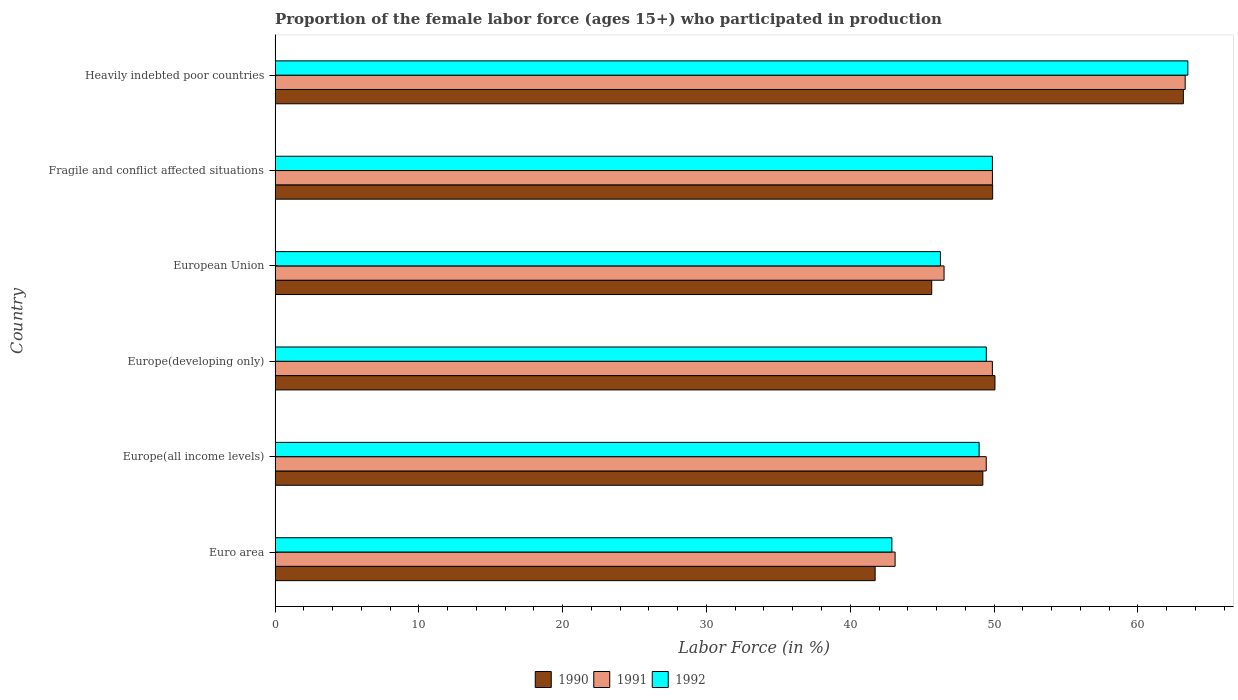How many groups of bars are there?
Your answer should be compact. 6. Are the number of bars per tick equal to the number of legend labels?
Make the answer very short. Yes. Are the number of bars on each tick of the Y-axis equal?
Your response must be concise. Yes. How many bars are there on the 1st tick from the bottom?
Ensure brevity in your answer.  3. What is the label of the 2nd group of bars from the top?
Ensure brevity in your answer.  Fragile and conflict affected situations. What is the proportion of the female labor force who participated in production in 1992 in Heavily indebted poor countries?
Make the answer very short. 63.48. Across all countries, what is the maximum proportion of the female labor force who participated in production in 1990?
Keep it short and to the point. 63.16. Across all countries, what is the minimum proportion of the female labor force who participated in production in 1991?
Offer a terse response. 43.12. In which country was the proportion of the female labor force who participated in production in 1990 maximum?
Provide a short and direct response. Heavily indebted poor countries. What is the total proportion of the female labor force who participated in production in 1990 in the graph?
Offer a terse response. 299.74. What is the difference between the proportion of the female labor force who participated in production in 1990 in Euro area and that in Europe(developing only)?
Your response must be concise. -8.33. What is the difference between the proportion of the female labor force who participated in production in 1990 in Euro area and the proportion of the female labor force who participated in production in 1992 in Fragile and conflict affected situations?
Give a very brief answer. -8.15. What is the average proportion of the female labor force who participated in production in 1992 per country?
Your answer should be compact. 50.16. What is the difference between the proportion of the female labor force who participated in production in 1991 and proportion of the female labor force who participated in production in 1992 in Europe(developing only)?
Your response must be concise. 0.42. What is the ratio of the proportion of the female labor force who participated in production in 1992 in Europe(all income levels) to that in Fragile and conflict affected situations?
Give a very brief answer. 0.98. Is the proportion of the female labor force who participated in production in 1992 in Euro area less than that in Heavily indebted poor countries?
Give a very brief answer. Yes. What is the difference between the highest and the second highest proportion of the female labor force who participated in production in 1991?
Offer a terse response. 13.4. What is the difference between the highest and the lowest proportion of the female labor force who participated in production in 1991?
Offer a very short reply. 20.17. In how many countries, is the proportion of the female labor force who participated in production in 1992 greater than the average proportion of the female labor force who participated in production in 1992 taken over all countries?
Keep it short and to the point. 1. Is the sum of the proportion of the female labor force who participated in production in 1992 in Europe(developing only) and Fragile and conflict affected situations greater than the maximum proportion of the female labor force who participated in production in 1991 across all countries?
Ensure brevity in your answer.  Yes. What does the 1st bar from the top in Europe(developing only) represents?
Your answer should be very brief. 1992. What does the 1st bar from the bottom in Europe(all income levels) represents?
Provide a succinct answer. 1990. How many bars are there?
Provide a succinct answer. 18. Are all the bars in the graph horizontal?
Ensure brevity in your answer.  Yes. How many countries are there in the graph?
Make the answer very short. 6. Where does the legend appear in the graph?
Offer a very short reply. Bottom center. What is the title of the graph?
Provide a succinct answer. Proportion of the female labor force (ages 15+) who participated in production. What is the label or title of the X-axis?
Provide a short and direct response. Labor Force (in %). What is the Labor Force (in %) of 1990 in Euro area?
Your answer should be compact. 41.73. What is the Labor Force (in %) of 1991 in Euro area?
Your answer should be very brief. 43.12. What is the Labor Force (in %) in 1992 in Euro area?
Give a very brief answer. 42.89. What is the Labor Force (in %) of 1990 in Europe(all income levels)?
Give a very brief answer. 49.22. What is the Labor Force (in %) of 1991 in Europe(all income levels)?
Offer a terse response. 49.46. What is the Labor Force (in %) in 1992 in Europe(all income levels)?
Provide a short and direct response. 48.96. What is the Labor Force (in %) of 1990 in Europe(developing only)?
Make the answer very short. 50.06. What is the Labor Force (in %) in 1991 in Europe(developing only)?
Ensure brevity in your answer.  49.88. What is the Labor Force (in %) in 1992 in Europe(developing only)?
Ensure brevity in your answer.  49.46. What is the Labor Force (in %) in 1990 in European Union?
Offer a terse response. 45.66. What is the Labor Force (in %) of 1991 in European Union?
Provide a short and direct response. 46.52. What is the Labor Force (in %) of 1992 in European Union?
Offer a very short reply. 46.27. What is the Labor Force (in %) in 1990 in Fragile and conflict affected situations?
Offer a terse response. 49.9. What is the Labor Force (in %) of 1991 in Fragile and conflict affected situations?
Make the answer very short. 49.89. What is the Labor Force (in %) of 1992 in Fragile and conflict affected situations?
Give a very brief answer. 49.88. What is the Labor Force (in %) of 1990 in Heavily indebted poor countries?
Offer a terse response. 63.16. What is the Labor Force (in %) in 1991 in Heavily indebted poor countries?
Your response must be concise. 63.29. What is the Labor Force (in %) in 1992 in Heavily indebted poor countries?
Your answer should be compact. 63.48. Across all countries, what is the maximum Labor Force (in %) of 1990?
Ensure brevity in your answer.  63.16. Across all countries, what is the maximum Labor Force (in %) of 1991?
Keep it short and to the point. 63.29. Across all countries, what is the maximum Labor Force (in %) of 1992?
Offer a very short reply. 63.48. Across all countries, what is the minimum Labor Force (in %) of 1990?
Provide a succinct answer. 41.73. Across all countries, what is the minimum Labor Force (in %) of 1991?
Provide a short and direct response. 43.12. Across all countries, what is the minimum Labor Force (in %) in 1992?
Provide a short and direct response. 42.89. What is the total Labor Force (in %) in 1990 in the graph?
Your answer should be compact. 299.74. What is the total Labor Force (in %) of 1991 in the graph?
Your response must be concise. 302.16. What is the total Labor Force (in %) in 1992 in the graph?
Offer a very short reply. 300.95. What is the difference between the Labor Force (in %) in 1990 in Euro area and that in Europe(all income levels)?
Offer a terse response. -7.49. What is the difference between the Labor Force (in %) of 1991 in Euro area and that in Europe(all income levels)?
Your answer should be very brief. -6.34. What is the difference between the Labor Force (in %) in 1992 in Euro area and that in Europe(all income levels)?
Offer a very short reply. -6.07. What is the difference between the Labor Force (in %) in 1990 in Euro area and that in Europe(developing only)?
Give a very brief answer. -8.33. What is the difference between the Labor Force (in %) in 1991 in Euro area and that in Europe(developing only)?
Provide a succinct answer. -6.76. What is the difference between the Labor Force (in %) in 1992 in Euro area and that in Europe(developing only)?
Provide a short and direct response. -6.57. What is the difference between the Labor Force (in %) of 1990 in Euro area and that in European Union?
Keep it short and to the point. -3.93. What is the difference between the Labor Force (in %) of 1991 in Euro area and that in European Union?
Your answer should be compact. -3.4. What is the difference between the Labor Force (in %) of 1992 in Euro area and that in European Union?
Offer a terse response. -3.38. What is the difference between the Labor Force (in %) of 1990 in Euro area and that in Fragile and conflict affected situations?
Make the answer very short. -8.17. What is the difference between the Labor Force (in %) of 1991 in Euro area and that in Fragile and conflict affected situations?
Your answer should be very brief. -6.77. What is the difference between the Labor Force (in %) in 1992 in Euro area and that in Fragile and conflict affected situations?
Offer a terse response. -6.99. What is the difference between the Labor Force (in %) in 1990 in Euro area and that in Heavily indebted poor countries?
Offer a very short reply. -21.43. What is the difference between the Labor Force (in %) in 1991 in Euro area and that in Heavily indebted poor countries?
Ensure brevity in your answer.  -20.17. What is the difference between the Labor Force (in %) of 1992 in Euro area and that in Heavily indebted poor countries?
Offer a terse response. -20.58. What is the difference between the Labor Force (in %) of 1990 in Europe(all income levels) and that in Europe(developing only)?
Give a very brief answer. -0.84. What is the difference between the Labor Force (in %) of 1991 in Europe(all income levels) and that in Europe(developing only)?
Ensure brevity in your answer.  -0.43. What is the difference between the Labor Force (in %) in 1992 in Europe(all income levels) and that in Europe(developing only)?
Your answer should be very brief. -0.5. What is the difference between the Labor Force (in %) of 1990 in Europe(all income levels) and that in European Union?
Offer a very short reply. 3.56. What is the difference between the Labor Force (in %) of 1991 in Europe(all income levels) and that in European Union?
Provide a short and direct response. 2.93. What is the difference between the Labor Force (in %) in 1992 in Europe(all income levels) and that in European Union?
Offer a very short reply. 2.69. What is the difference between the Labor Force (in %) of 1990 in Europe(all income levels) and that in Fragile and conflict affected situations?
Offer a terse response. -0.68. What is the difference between the Labor Force (in %) of 1991 in Europe(all income levels) and that in Fragile and conflict affected situations?
Your answer should be very brief. -0.43. What is the difference between the Labor Force (in %) of 1992 in Europe(all income levels) and that in Fragile and conflict affected situations?
Your response must be concise. -0.92. What is the difference between the Labor Force (in %) of 1990 in Europe(all income levels) and that in Heavily indebted poor countries?
Give a very brief answer. -13.94. What is the difference between the Labor Force (in %) in 1991 in Europe(all income levels) and that in Heavily indebted poor countries?
Your response must be concise. -13.83. What is the difference between the Labor Force (in %) in 1992 in Europe(all income levels) and that in Heavily indebted poor countries?
Ensure brevity in your answer.  -14.52. What is the difference between the Labor Force (in %) in 1990 in Europe(developing only) and that in European Union?
Your answer should be compact. 4.4. What is the difference between the Labor Force (in %) in 1991 in Europe(developing only) and that in European Union?
Make the answer very short. 3.36. What is the difference between the Labor Force (in %) of 1992 in Europe(developing only) and that in European Union?
Offer a very short reply. 3.19. What is the difference between the Labor Force (in %) of 1990 in Europe(developing only) and that in Fragile and conflict affected situations?
Provide a short and direct response. 0.16. What is the difference between the Labor Force (in %) of 1991 in Europe(developing only) and that in Fragile and conflict affected situations?
Provide a succinct answer. -0. What is the difference between the Labor Force (in %) of 1992 in Europe(developing only) and that in Fragile and conflict affected situations?
Offer a very short reply. -0.42. What is the difference between the Labor Force (in %) of 1990 in Europe(developing only) and that in Heavily indebted poor countries?
Keep it short and to the point. -13.1. What is the difference between the Labor Force (in %) in 1991 in Europe(developing only) and that in Heavily indebted poor countries?
Your answer should be very brief. -13.41. What is the difference between the Labor Force (in %) in 1992 in Europe(developing only) and that in Heavily indebted poor countries?
Ensure brevity in your answer.  -14.02. What is the difference between the Labor Force (in %) of 1990 in European Union and that in Fragile and conflict affected situations?
Your answer should be very brief. -4.24. What is the difference between the Labor Force (in %) in 1991 in European Union and that in Fragile and conflict affected situations?
Provide a succinct answer. -3.36. What is the difference between the Labor Force (in %) in 1992 in European Union and that in Fragile and conflict affected situations?
Provide a succinct answer. -3.61. What is the difference between the Labor Force (in %) in 1990 in European Union and that in Heavily indebted poor countries?
Offer a terse response. -17.5. What is the difference between the Labor Force (in %) in 1991 in European Union and that in Heavily indebted poor countries?
Ensure brevity in your answer.  -16.77. What is the difference between the Labor Force (in %) of 1992 in European Union and that in Heavily indebted poor countries?
Give a very brief answer. -17.21. What is the difference between the Labor Force (in %) of 1990 in Fragile and conflict affected situations and that in Heavily indebted poor countries?
Your response must be concise. -13.26. What is the difference between the Labor Force (in %) in 1991 in Fragile and conflict affected situations and that in Heavily indebted poor countries?
Keep it short and to the point. -13.4. What is the difference between the Labor Force (in %) in 1992 in Fragile and conflict affected situations and that in Heavily indebted poor countries?
Ensure brevity in your answer.  -13.59. What is the difference between the Labor Force (in %) in 1990 in Euro area and the Labor Force (in %) in 1991 in Europe(all income levels)?
Offer a very short reply. -7.73. What is the difference between the Labor Force (in %) of 1990 in Euro area and the Labor Force (in %) of 1992 in Europe(all income levels)?
Ensure brevity in your answer.  -7.23. What is the difference between the Labor Force (in %) of 1991 in Euro area and the Labor Force (in %) of 1992 in Europe(all income levels)?
Your answer should be very brief. -5.84. What is the difference between the Labor Force (in %) of 1990 in Euro area and the Labor Force (in %) of 1991 in Europe(developing only)?
Ensure brevity in your answer.  -8.15. What is the difference between the Labor Force (in %) of 1990 in Euro area and the Labor Force (in %) of 1992 in Europe(developing only)?
Provide a succinct answer. -7.73. What is the difference between the Labor Force (in %) of 1991 in Euro area and the Labor Force (in %) of 1992 in Europe(developing only)?
Give a very brief answer. -6.34. What is the difference between the Labor Force (in %) of 1990 in Euro area and the Labor Force (in %) of 1991 in European Union?
Give a very brief answer. -4.79. What is the difference between the Labor Force (in %) of 1990 in Euro area and the Labor Force (in %) of 1992 in European Union?
Offer a terse response. -4.54. What is the difference between the Labor Force (in %) in 1991 in Euro area and the Labor Force (in %) in 1992 in European Union?
Give a very brief answer. -3.15. What is the difference between the Labor Force (in %) of 1990 in Euro area and the Labor Force (in %) of 1991 in Fragile and conflict affected situations?
Ensure brevity in your answer.  -8.16. What is the difference between the Labor Force (in %) of 1990 in Euro area and the Labor Force (in %) of 1992 in Fragile and conflict affected situations?
Ensure brevity in your answer.  -8.15. What is the difference between the Labor Force (in %) in 1991 in Euro area and the Labor Force (in %) in 1992 in Fragile and conflict affected situations?
Your response must be concise. -6.77. What is the difference between the Labor Force (in %) of 1990 in Euro area and the Labor Force (in %) of 1991 in Heavily indebted poor countries?
Your response must be concise. -21.56. What is the difference between the Labor Force (in %) of 1990 in Euro area and the Labor Force (in %) of 1992 in Heavily indebted poor countries?
Provide a short and direct response. -21.75. What is the difference between the Labor Force (in %) of 1991 in Euro area and the Labor Force (in %) of 1992 in Heavily indebted poor countries?
Offer a terse response. -20.36. What is the difference between the Labor Force (in %) in 1990 in Europe(all income levels) and the Labor Force (in %) in 1991 in Europe(developing only)?
Give a very brief answer. -0.66. What is the difference between the Labor Force (in %) in 1990 in Europe(all income levels) and the Labor Force (in %) in 1992 in Europe(developing only)?
Your answer should be compact. -0.24. What is the difference between the Labor Force (in %) in 1991 in Europe(all income levels) and the Labor Force (in %) in 1992 in Europe(developing only)?
Provide a succinct answer. -0.01. What is the difference between the Labor Force (in %) of 1990 in Europe(all income levels) and the Labor Force (in %) of 1991 in European Union?
Your answer should be very brief. 2.7. What is the difference between the Labor Force (in %) in 1990 in Europe(all income levels) and the Labor Force (in %) in 1992 in European Union?
Offer a terse response. 2.95. What is the difference between the Labor Force (in %) in 1991 in Europe(all income levels) and the Labor Force (in %) in 1992 in European Union?
Your answer should be very brief. 3.19. What is the difference between the Labor Force (in %) in 1990 in Europe(all income levels) and the Labor Force (in %) in 1991 in Fragile and conflict affected situations?
Provide a short and direct response. -0.67. What is the difference between the Labor Force (in %) in 1990 in Europe(all income levels) and the Labor Force (in %) in 1992 in Fragile and conflict affected situations?
Your answer should be very brief. -0.66. What is the difference between the Labor Force (in %) of 1991 in Europe(all income levels) and the Labor Force (in %) of 1992 in Fragile and conflict affected situations?
Give a very brief answer. -0.43. What is the difference between the Labor Force (in %) in 1990 in Europe(all income levels) and the Labor Force (in %) in 1991 in Heavily indebted poor countries?
Offer a terse response. -14.07. What is the difference between the Labor Force (in %) in 1990 in Europe(all income levels) and the Labor Force (in %) in 1992 in Heavily indebted poor countries?
Your answer should be compact. -14.26. What is the difference between the Labor Force (in %) in 1991 in Europe(all income levels) and the Labor Force (in %) in 1992 in Heavily indebted poor countries?
Make the answer very short. -14.02. What is the difference between the Labor Force (in %) in 1990 in Europe(developing only) and the Labor Force (in %) in 1991 in European Union?
Give a very brief answer. 3.54. What is the difference between the Labor Force (in %) in 1990 in Europe(developing only) and the Labor Force (in %) in 1992 in European Union?
Offer a very short reply. 3.79. What is the difference between the Labor Force (in %) in 1991 in Europe(developing only) and the Labor Force (in %) in 1992 in European Union?
Your answer should be compact. 3.61. What is the difference between the Labor Force (in %) in 1990 in Europe(developing only) and the Labor Force (in %) in 1991 in Fragile and conflict affected situations?
Offer a very short reply. 0.18. What is the difference between the Labor Force (in %) of 1990 in Europe(developing only) and the Labor Force (in %) of 1992 in Fragile and conflict affected situations?
Give a very brief answer. 0.18. What is the difference between the Labor Force (in %) of 1991 in Europe(developing only) and the Labor Force (in %) of 1992 in Fragile and conflict affected situations?
Provide a short and direct response. -0. What is the difference between the Labor Force (in %) of 1990 in Europe(developing only) and the Labor Force (in %) of 1991 in Heavily indebted poor countries?
Offer a very short reply. -13.23. What is the difference between the Labor Force (in %) of 1990 in Europe(developing only) and the Labor Force (in %) of 1992 in Heavily indebted poor countries?
Ensure brevity in your answer.  -13.42. What is the difference between the Labor Force (in %) of 1991 in Europe(developing only) and the Labor Force (in %) of 1992 in Heavily indebted poor countries?
Your answer should be compact. -13.59. What is the difference between the Labor Force (in %) in 1990 in European Union and the Labor Force (in %) in 1991 in Fragile and conflict affected situations?
Provide a short and direct response. -4.22. What is the difference between the Labor Force (in %) of 1990 in European Union and the Labor Force (in %) of 1992 in Fragile and conflict affected situations?
Make the answer very short. -4.22. What is the difference between the Labor Force (in %) of 1991 in European Union and the Labor Force (in %) of 1992 in Fragile and conflict affected situations?
Your answer should be compact. -3.36. What is the difference between the Labor Force (in %) in 1990 in European Union and the Labor Force (in %) in 1991 in Heavily indebted poor countries?
Provide a succinct answer. -17.63. What is the difference between the Labor Force (in %) of 1990 in European Union and the Labor Force (in %) of 1992 in Heavily indebted poor countries?
Offer a terse response. -17.81. What is the difference between the Labor Force (in %) in 1991 in European Union and the Labor Force (in %) in 1992 in Heavily indebted poor countries?
Offer a very short reply. -16.95. What is the difference between the Labor Force (in %) in 1990 in Fragile and conflict affected situations and the Labor Force (in %) in 1991 in Heavily indebted poor countries?
Ensure brevity in your answer.  -13.39. What is the difference between the Labor Force (in %) of 1990 in Fragile and conflict affected situations and the Labor Force (in %) of 1992 in Heavily indebted poor countries?
Offer a very short reply. -13.57. What is the difference between the Labor Force (in %) in 1991 in Fragile and conflict affected situations and the Labor Force (in %) in 1992 in Heavily indebted poor countries?
Give a very brief answer. -13.59. What is the average Labor Force (in %) of 1990 per country?
Your response must be concise. 49.96. What is the average Labor Force (in %) of 1991 per country?
Keep it short and to the point. 50.36. What is the average Labor Force (in %) of 1992 per country?
Provide a succinct answer. 50.16. What is the difference between the Labor Force (in %) in 1990 and Labor Force (in %) in 1991 in Euro area?
Your response must be concise. -1.39. What is the difference between the Labor Force (in %) of 1990 and Labor Force (in %) of 1992 in Euro area?
Your response must be concise. -1.16. What is the difference between the Labor Force (in %) of 1991 and Labor Force (in %) of 1992 in Euro area?
Provide a succinct answer. 0.22. What is the difference between the Labor Force (in %) in 1990 and Labor Force (in %) in 1991 in Europe(all income levels)?
Give a very brief answer. -0.24. What is the difference between the Labor Force (in %) in 1990 and Labor Force (in %) in 1992 in Europe(all income levels)?
Keep it short and to the point. 0.26. What is the difference between the Labor Force (in %) of 1991 and Labor Force (in %) of 1992 in Europe(all income levels)?
Your response must be concise. 0.49. What is the difference between the Labor Force (in %) of 1990 and Labor Force (in %) of 1991 in Europe(developing only)?
Ensure brevity in your answer.  0.18. What is the difference between the Labor Force (in %) of 1990 and Labor Force (in %) of 1992 in Europe(developing only)?
Offer a terse response. 0.6. What is the difference between the Labor Force (in %) of 1991 and Labor Force (in %) of 1992 in Europe(developing only)?
Provide a short and direct response. 0.42. What is the difference between the Labor Force (in %) of 1990 and Labor Force (in %) of 1991 in European Union?
Offer a very short reply. -0.86. What is the difference between the Labor Force (in %) of 1990 and Labor Force (in %) of 1992 in European Union?
Your response must be concise. -0.61. What is the difference between the Labor Force (in %) in 1991 and Labor Force (in %) in 1992 in European Union?
Your answer should be compact. 0.25. What is the difference between the Labor Force (in %) of 1990 and Labor Force (in %) of 1991 in Fragile and conflict affected situations?
Give a very brief answer. 0.02. What is the difference between the Labor Force (in %) of 1990 and Labor Force (in %) of 1992 in Fragile and conflict affected situations?
Keep it short and to the point. 0.02. What is the difference between the Labor Force (in %) in 1991 and Labor Force (in %) in 1992 in Fragile and conflict affected situations?
Your response must be concise. 0. What is the difference between the Labor Force (in %) in 1990 and Labor Force (in %) in 1991 in Heavily indebted poor countries?
Your response must be concise. -0.13. What is the difference between the Labor Force (in %) in 1990 and Labor Force (in %) in 1992 in Heavily indebted poor countries?
Give a very brief answer. -0.31. What is the difference between the Labor Force (in %) of 1991 and Labor Force (in %) of 1992 in Heavily indebted poor countries?
Provide a short and direct response. -0.19. What is the ratio of the Labor Force (in %) of 1990 in Euro area to that in Europe(all income levels)?
Ensure brevity in your answer.  0.85. What is the ratio of the Labor Force (in %) of 1991 in Euro area to that in Europe(all income levels)?
Give a very brief answer. 0.87. What is the ratio of the Labor Force (in %) of 1992 in Euro area to that in Europe(all income levels)?
Offer a terse response. 0.88. What is the ratio of the Labor Force (in %) of 1990 in Euro area to that in Europe(developing only)?
Your response must be concise. 0.83. What is the ratio of the Labor Force (in %) in 1991 in Euro area to that in Europe(developing only)?
Provide a short and direct response. 0.86. What is the ratio of the Labor Force (in %) in 1992 in Euro area to that in Europe(developing only)?
Your response must be concise. 0.87. What is the ratio of the Labor Force (in %) in 1990 in Euro area to that in European Union?
Offer a very short reply. 0.91. What is the ratio of the Labor Force (in %) of 1991 in Euro area to that in European Union?
Provide a succinct answer. 0.93. What is the ratio of the Labor Force (in %) of 1992 in Euro area to that in European Union?
Your answer should be very brief. 0.93. What is the ratio of the Labor Force (in %) in 1990 in Euro area to that in Fragile and conflict affected situations?
Provide a succinct answer. 0.84. What is the ratio of the Labor Force (in %) of 1991 in Euro area to that in Fragile and conflict affected situations?
Keep it short and to the point. 0.86. What is the ratio of the Labor Force (in %) of 1992 in Euro area to that in Fragile and conflict affected situations?
Keep it short and to the point. 0.86. What is the ratio of the Labor Force (in %) of 1990 in Euro area to that in Heavily indebted poor countries?
Give a very brief answer. 0.66. What is the ratio of the Labor Force (in %) in 1991 in Euro area to that in Heavily indebted poor countries?
Ensure brevity in your answer.  0.68. What is the ratio of the Labor Force (in %) of 1992 in Euro area to that in Heavily indebted poor countries?
Your response must be concise. 0.68. What is the ratio of the Labor Force (in %) of 1990 in Europe(all income levels) to that in Europe(developing only)?
Make the answer very short. 0.98. What is the ratio of the Labor Force (in %) in 1992 in Europe(all income levels) to that in Europe(developing only)?
Offer a terse response. 0.99. What is the ratio of the Labor Force (in %) of 1990 in Europe(all income levels) to that in European Union?
Give a very brief answer. 1.08. What is the ratio of the Labor Force (in %) in 1991 in Europe(all income levels) to that in European Union?
Make the answer very short. 1.06. What is the ratio of the Labor Force (in %) in 1992 in Europe(all income levels) to that in European Union?
Offer a terse response. 1.06. What is the ratio of the Labor Force (in %) in 1990 in Europe(all income levels) to that in Fragile and conflict affected situations?
Provide a succinct answer. 0.99. What is the ratio of the Labor Force (in %) in 1991 in Europe(all income levels) to that in Fragile and conflict affected situations?
Your answer should be very brief. 0.99. What is the ratio of the Labor Force (in %) of 1992 in Europe(all income levels) to that in Fragile and conflict affected situations?
Keep it short and to the point. 0.98. What is the ratio of the Labor Force (in %) in 1990 in Europe(all income levels) to that in Heavily indebted poor countries?
Your answer should be compact. 0.78. What is the ratio of the Labor Force (in %) of 1991 in Europe(all income levels) to that in Heavily indebted poor countries?
Provide a short and direct response. 0.78. What is the ratio of the Labor Force (in %) of 1992 in Europe(all income levels) to that in Heavily indebted poor countries?
Provide a short and direct response. 0.77. What is the ratio of the Labor Force (in %) in 1990 in Europe(developing only) to that in European Union?
Give a very brief answer. 1.1. What is the ratio of the Labor Force (in %) in 1991 in Europe(developing only) to that in European Union?
Offer a terse response. 1.07. What is the ratio of the Labor Force (in %) of 1992 in Europe(developing only) to that in European Union?
Your answer should be compact. 1.07. What is the ratio of the Labor Force (in %) of 1992 in Europe(developing only) to that in Fragile and conflict affected situations?
Give a very brief answer. 0.99. What is the ratio of the Labor Force (in %) of 1990 in Europe(developing only) to that in Heavily indebted poor countries?
Make the answer very short. 0.79. What is the ratio of the Labor Force (in %) in 1991 in Europe(developing only) to that in Heavily indebted poor countries?
Give a very brief answer. 0.79. What is the ratio of the Labor Force (in %) of 1992 in Europe(developing only) to that in Heavily indebted poor countries?
Keep it short and to the point. 0.78. What is the ratio of the Labor Force (in %) of 1990 in European Union to that in Fragile and conflict affected situations?
Keep it short and to the point. 0.92. What is the ratio of the Labor Force (in %) of 1991 in European Union to that in Fragile and conflict affected situations?
Your answer should be compact. 0.93. What is the ratio of the Labor Force (in %) of 1992 in European Union to that in Fragile and conflict affected situations?
Your answer should be compact. 0.93. What is the ratio of the Labor Force (in %) of 1990 in European Union to that in Heavily indebted poor countries?
Your answer should be compact. 0.72. What is the ratio of the Labor Force (in %) in 1991 in European Union to that in Heavily indebted poor countries?
Offer a terse response. 0.74. What is the ratio of the Labor Force (in %) of 1992 in European Union to that in Heavily indebted poor countries?
Provide a succinct answer. 0.73. What is the ratio of the Labor Force (in %) of 1990 in Fragile and conflict affected situations to that in Heavily indebted poor countries?
Make the answer very short. 0.79. What is the ratio of the Labor Force (in %) in 1991 in Fragile and conflict affected situations to that in Heavily indebted poor countries?
Your response must be concise. 0.79. What is the ratio of the Labor Force (in %) of 1992 in Fragile and conflict affected situations to that in Heavily indebted poor countries?
Ensure brevity in your answer.  0.79. What is the difference between the highest and the second highest Labor Force (in %) of 1990?
Provide a short and direct response. 13.1. What is the difference between the highest and the second highest Labor Force (in %) of 1991?
Your response must be concise. 13.4. What is the difference between the highest and the second highest Labor Force (in %) in 1992?
Offer a terse response. 13.59. What is the difference between the highest and the lowest Labor Force (in %) in 1990?
Provide a succinct answer. 21.43. What is the difference between the highest and the lowest Labor Force (in %) of 1991?
Your response must be concise. 20.17. What is the difference between the highest and the lowest Labor Force (in %) in 1992?
Your response must be concise. 20.58. 